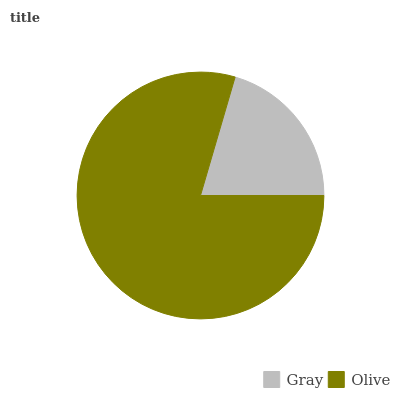Is Gray the minimum?
Answer yes or no. Yes. Is Olive the maximum?
Answer yes or no. Yes. Is Olive the minimum?
Answer yes or no. No. Is Olive greater than Gray?
Answer yes or no. Yes. Is Gray less than Olive?
Answer yes or no. Yes. Is Gray greater than Olive?
Answer yes or no. No. Is Olive less than Gray?
Answer yes or no. No. Is Olive the high median?
Answer yes or no. Yes. Is Gray the low median?
Answer yes or no. Yes. Is Gray the high median?
Answer yes or no. No. Is Olive the low median?
Answer yes or no. No. 